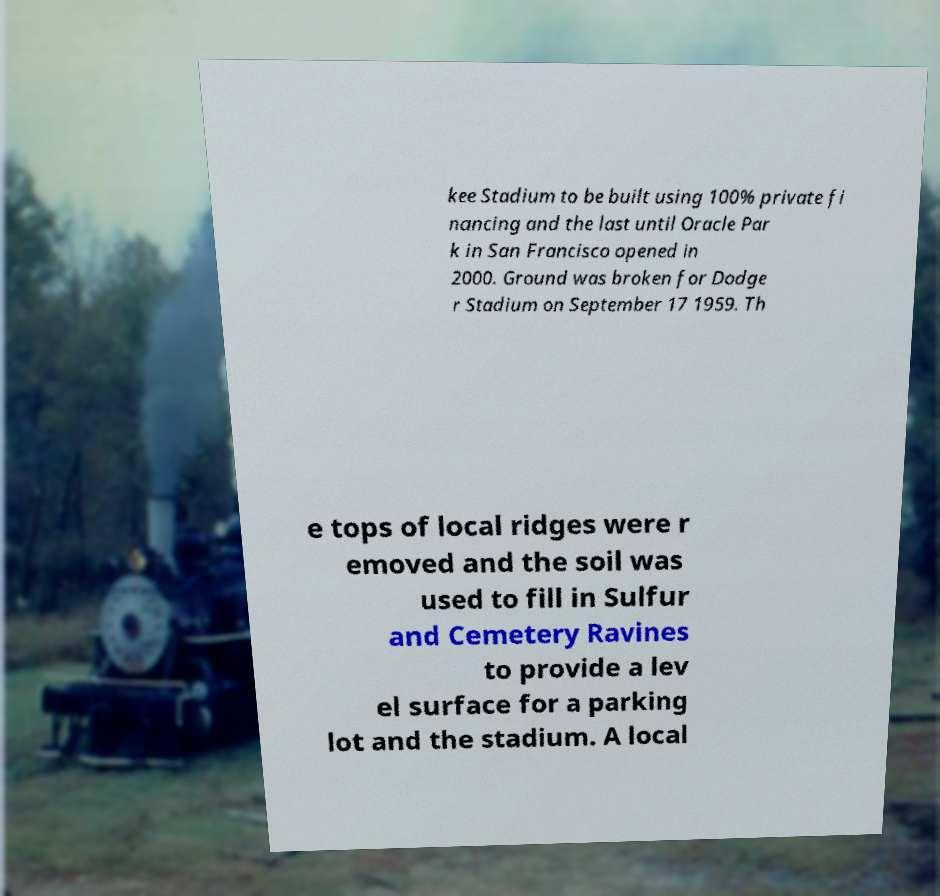I need the written content from this picture converted into text. Can you do that? kee Stadium to be built using 100% private fi nancing and the last until Oracle Par k in San Francisco opened in 2000. Ground was broken for Dodge r Stadium on September 17 1959. Th e tops of local ridges were r emoved and the soil was used to fill in Sulfur and Cemetery Ravines to provide a lev el surface for a parking lot and the stadium. A local 